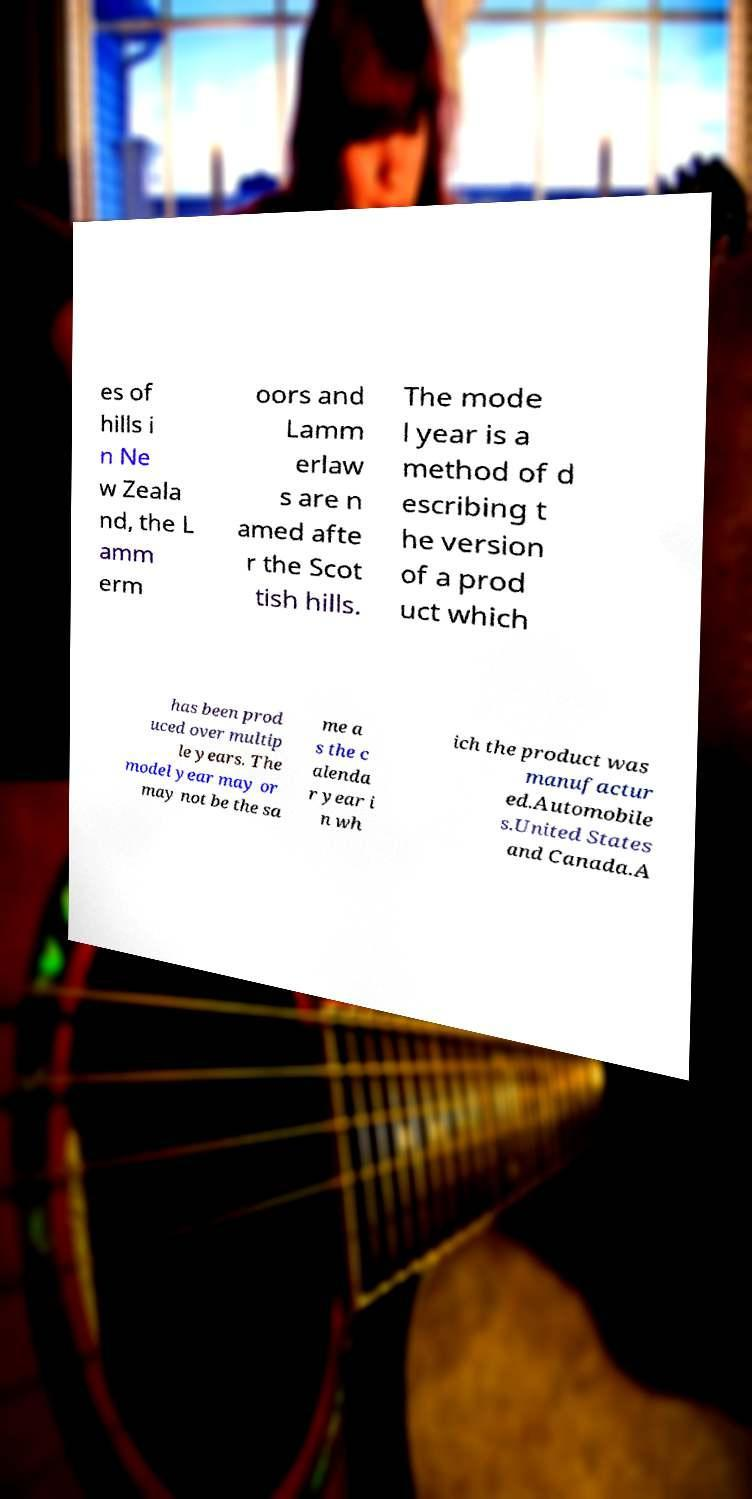There's text embedded in this image that I need extracted. Can you transcribe it verbatim? es of hills i n Ne w Zeala nd, the L amm erm oors and Lamm erlaw s are n amed afte r the Scot tish hills. The mode l year is a method of d escribing t he version of a prod uct which has been prod uced over multip le years. The model year may or may not be the sa me a s the c alenda r year i n wh ich the product was manufactur ed.Automobile s.United States and Canada.A 